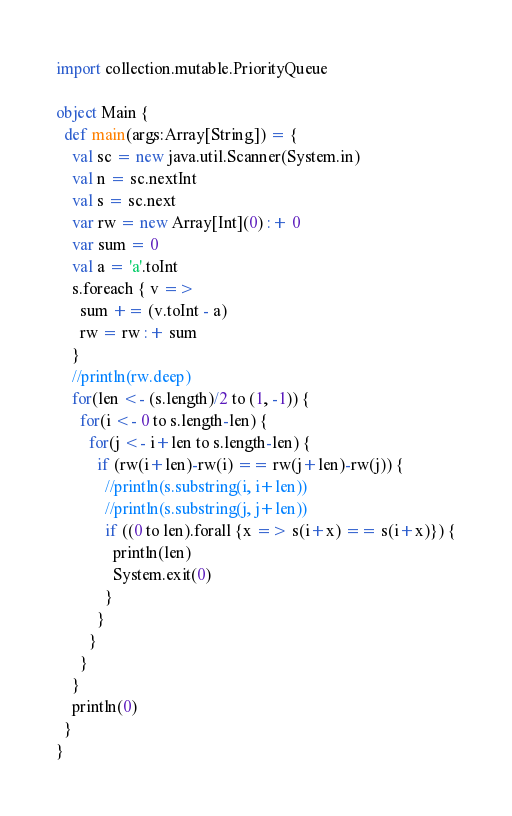<code> <loc_0><loc_0><loc_500><loc_500><_Scala_>import collection.mutable.PriorityQueue

object Main {
  def main(args:Array[String]) = {
    val sc = new java.util.Scanner(System.in)
    val n = sc.nextInt
    val s = sc.next
    var rw = new Array[Int](0) :+ 0
    var sum = 0
    val a = 'a'.toInt
    s.foreach { v =>
      sum += (v.toInt - a)
      rw = rw :+ sum
    }
    //println(rw.deep)
    for(len <- (s.length)/2 to (1, -1)) {
      for(i <- 0 to s.length-len) {
        for(j <- i+len to s.length-len) {
          if (rw(i+len)-rw(i) == rw(j+len)-rw(j)) {
            //println(s.substring(i, i+len))
            //println(s.substring(j, j+len))
            if ((0 to len).forall {x => s(i+x) == s(i+x)}) {
              println(len)
              System.exit(0)
            }
          }
        }
      }
    }
    println(0)
  }
}
</code> 